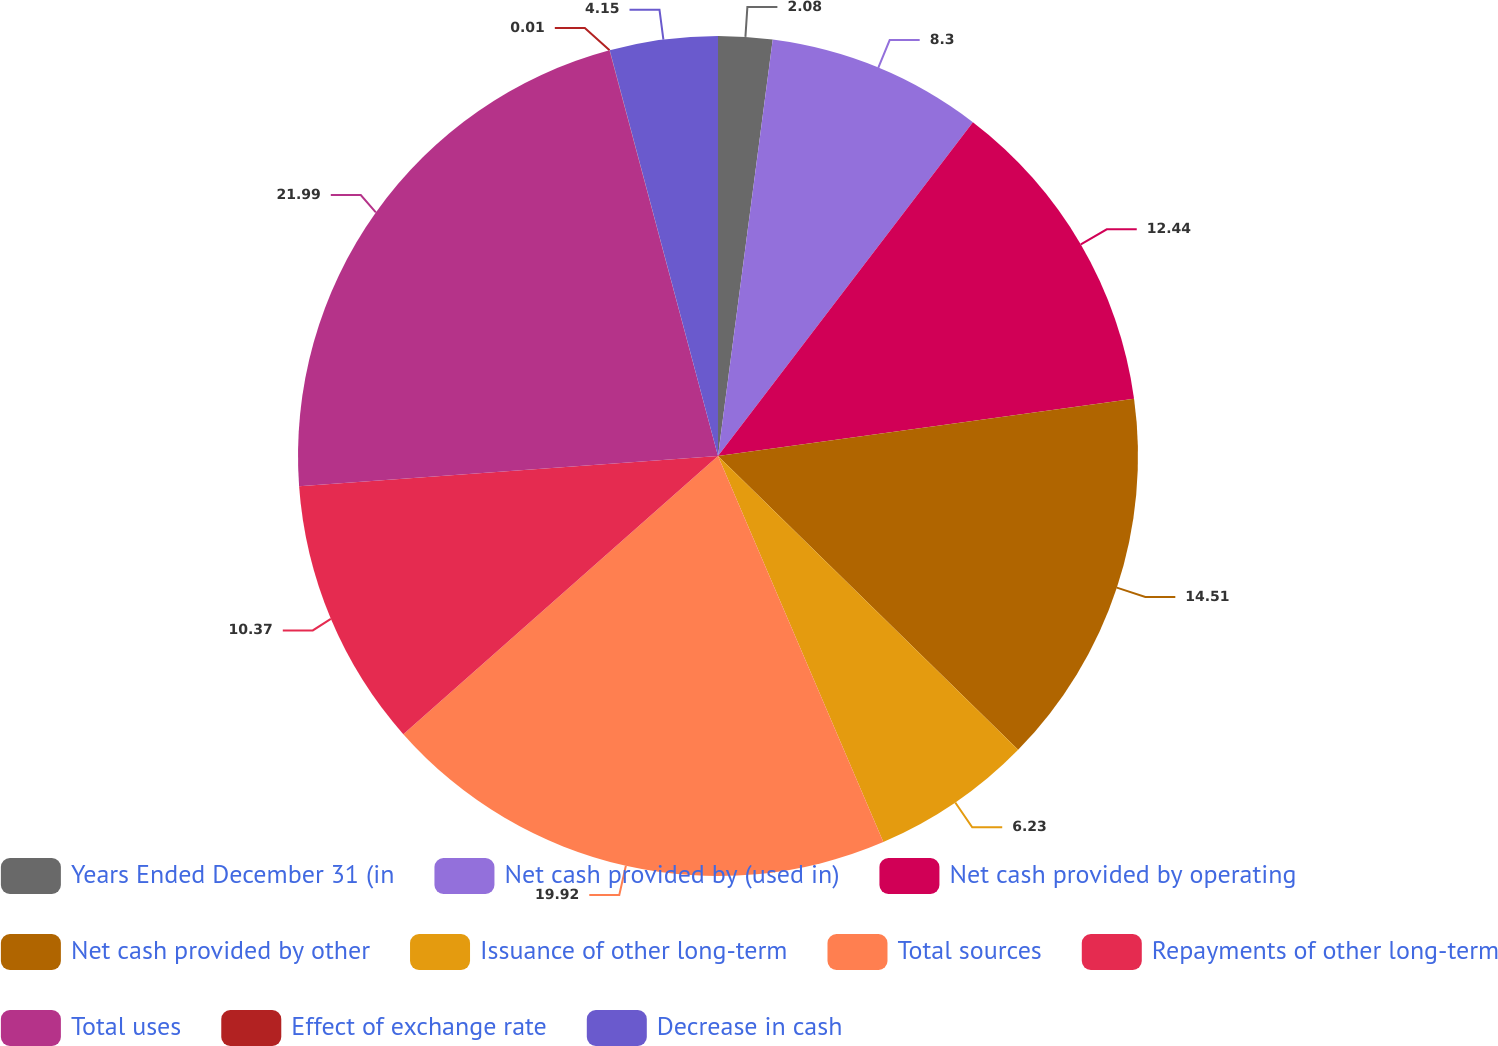Convert chart to OTSL. <chart><loc_0><loc_0><loc_500><loc_500><pie_chart><fcel>Years Ended December 31 (in<fcel>Net cash provided by (used in)<fcel>Net cash provided by operating<fcel>Net cash provided by other<fcel>Issuance of other long-term<fcel>Total sources<fcel>Repayments of other long-term<fcel>Total uses<fcel>Effect of exchange rate<fcel>Decrease in cash<nl><fcel>2.08%<fcel>8.3%<fcel>12.44%<fcel>14.51%<fcel>6.23%<fcel>19.92%<fcel>10.37%<fcel>21.99%<fcel>0.01%<fcel>4.15%<nl></chart> 